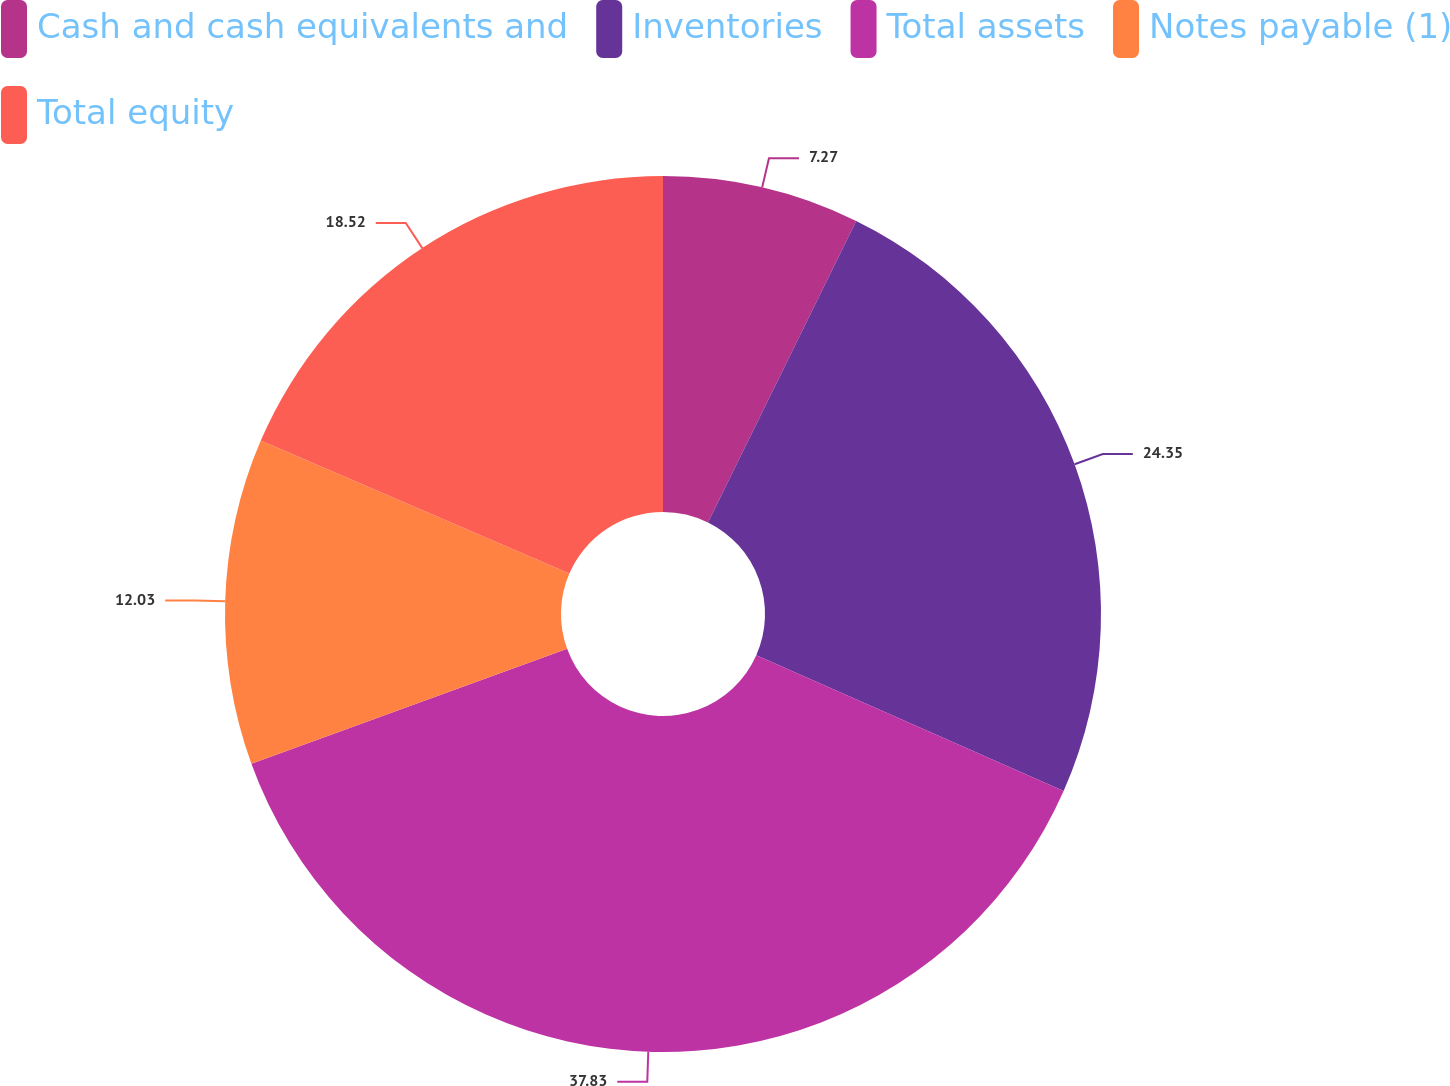Convert chart to OTSL. <chart><loc_0><loc_0><loc_500><loc_500><pie_chart><fcel>Cash and cash equivalents and<fcel>Inventories<fcel>Total assets<fcel>Notes payable (1)<fcel>Total equity<nl><fcel>7.27%<fcel>24.35%<fcel>37.82%<fcel>12.03%<fcel>18.52%<nl></chart> 